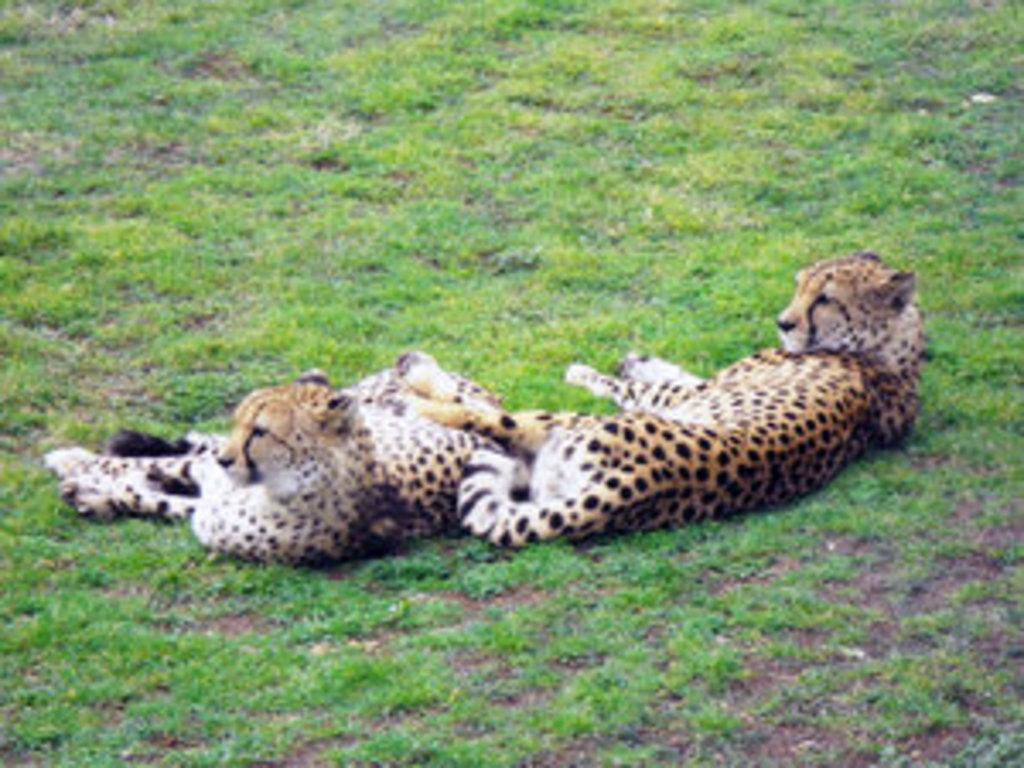Please provide a concise description of this image. In the center of the picture there are cheetahs. In this picture there is grass. 